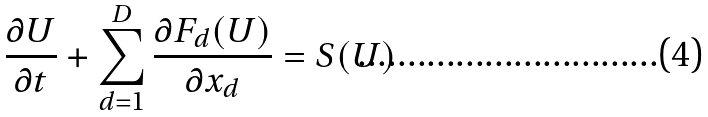Convert formula to latex. <formula><loc_0><loc_0><loc_500><loc_500>\frac { \partial U } { \partial t } + \sum _ { d = 1 } ^ { D } \frac { \partial F _ { d } ( U ) } { \partial x _ { d } } = S ( U )</formula> 